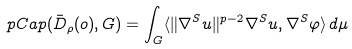<formula> <loc_0><loc_0><loc_500><loc_500>\ p C a p ( \bar { D } _ { \rho } ( o ) , G ) = \int _ { G } \langle \| \nabla ^ { S } u \| ^ { p - 2 } \nabla ^ { S } u , \nabla ^ { S } \varphi \rangle \, d \mu</formula> 